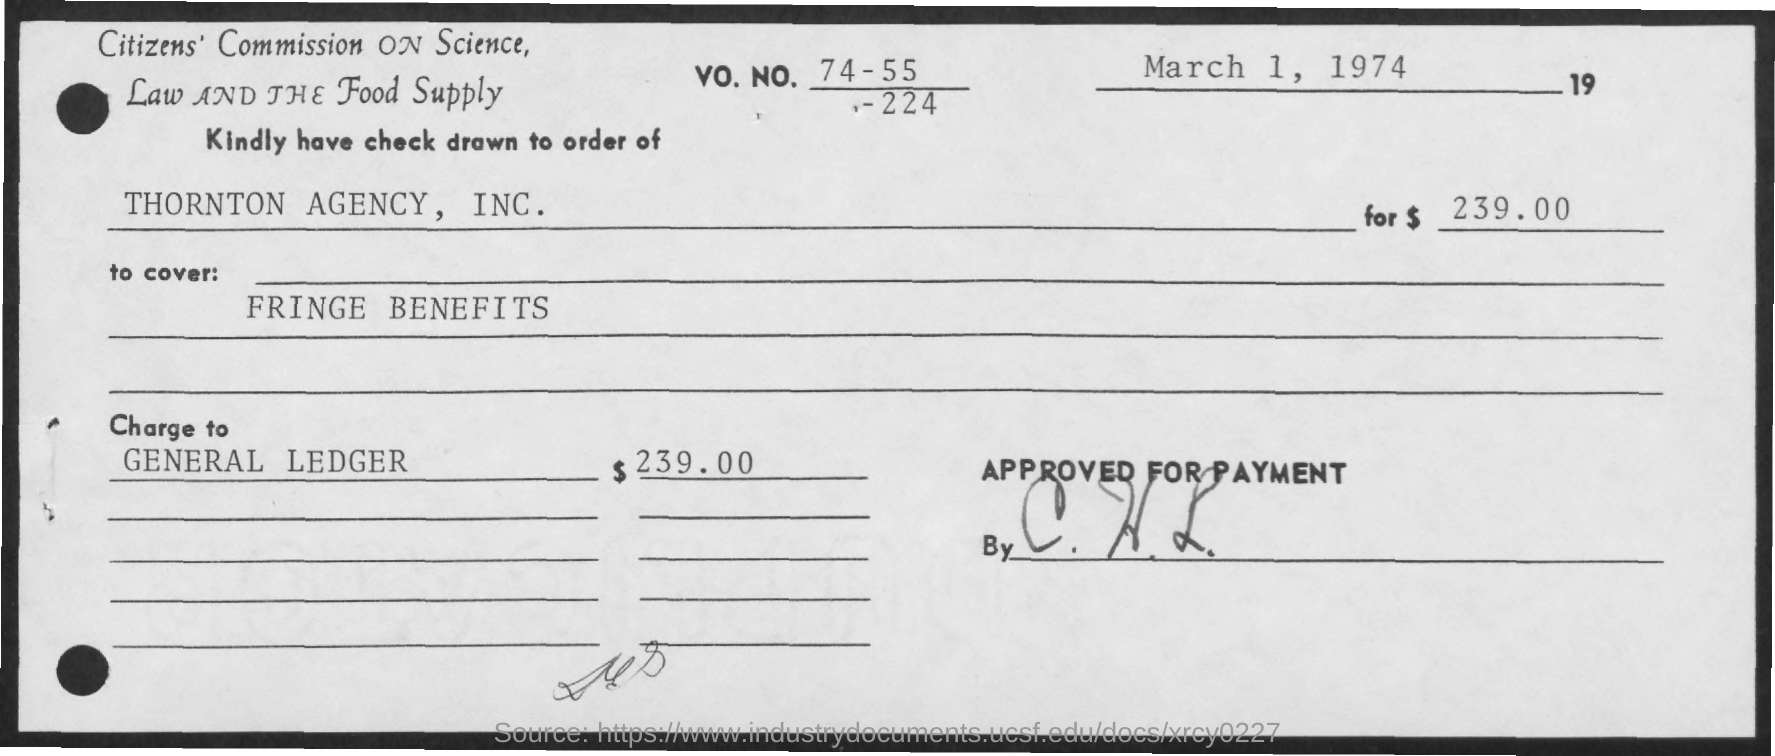Indicate a few pertinent items in this graphic. The check indicated that $239.00 in dollars were written. The check is issued by THORNTON AGENCY, INC. The check was issued on March 1, 1974. 